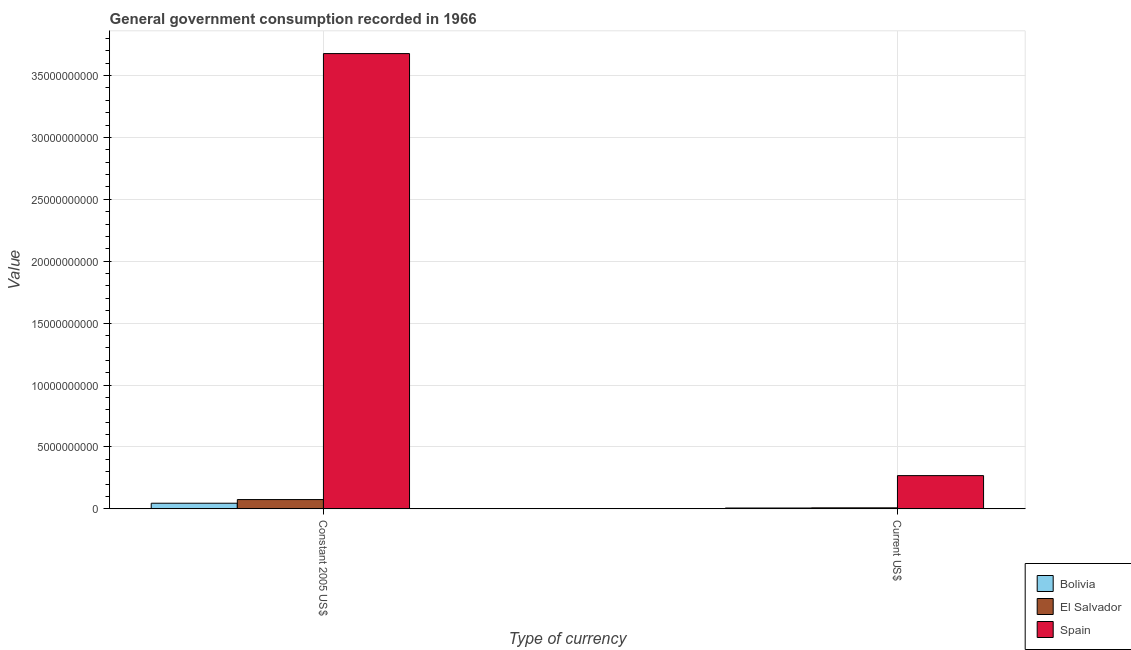Are the number of bars per tick equal to the number of legend labels?
Provide a succinct answer. Yes. Are the number of bars on each tick of the X-axis equal?
Offer a very short reply. Yes. How many bars are there on the 1st tick from the left?
Ensure brevity in your answer.  3. What is the label of the 2nd group of bars from the left?
Provide a succinct answer. Current US$. What is the value consumed in current us$ in Spain?
Your answer should be very brief. 2.68e+09. Across all countries, what is the maximum value consumed in constant 2005 us$?
Your answer should be very brief. 3.68e+1. Across all countries, what is the minimum value consumed in constant 2005 us$?
Your answer should be very brief. 4.54e+08. In which country was the value consumed in current us$ minimum?
Keep it short and to the point. Bolivia. What is the total value consumed in current us$ in the graph?
Your response must be concise. 2.83e+09. What is the difference between the value consumed in constant 2005 us$ in Spain and that in Bolivia?
Provide a succinct answer. 3.63e+1. What is the difference between the value consumed in current us$ in El Salvador and the value consumed in constant 2005 us$ in Bolivia?
Offer a terse response. -3.73e+08. What is the average value consumed in constant 2005 us$ per country?
Make the answer very short. 1.27e+1. What is the difference between the value consumed in constant 2005 us$ and value consumed in current us$ in Spain?
Your answer should be compact. 3.41e+1. In how many countries, is the value consumed in current us$ greater than 34000000000 ?
Make the answer very short. 0. What is the ratio of the value consumed in current us$ in Spain to that in Bolivia?
Ensure brevity in your answer.  39.85. Is the value consumed in current us$ in Bolivia less than that in Spain?
Provide a succinct answer. Yes. In how many countries, is the value consumed in constant 2005 us$ greater than the average value consumed in constant 2005 us$ taken over all countries?
Provide a short and direct response. 1. What is the difference between two consecutive major ticks on the Y-axis?
Offer a very short reply. 5.00e+09. Are the values on the major ticks of Y-axis written in scientific E-notation?
Make the answer very short. No. Does the graph contain any zero values?
Your answer should be very brief. No. Does the graph contain grids?
Your response must be concise. Yes. Where does the legend appear in the graph?
Your answer should be compact. Bottom right. How are the legend labels stacked?
Your answer should be compact. Vertical. What is the title of the graph?
Make the answer very short. General government consumption recorded in 1966. Does "Sweden" appear as one of the legend labels in the graph?
Provide a short and direct response. No. What is the label or title of the X-axis?
Offer a very short reply. Type of currency. What is the label or title of the Y-axis?
Ensure brevity in your answer.  Value. What is the Value of Bolivia in Constant 2005 US$?
Offer a very short reply. 4.54e+08. What is the Value in El Salvador in Constant 2005 US$?
Make the answer very short. 7.49e+08. What is the Value of Spain in Constant 2005 US$?
Give a very brief answer. 3.68e+1. What is the Value in Bolivia in Current US$?
Offer a terse response. 6.73e+07. What is the Value of El Salvador in Current US$?
Your answer should be compact. 8.10e+07. What is the Value in Spain in Current US$?
Make the answer very short. 2.68e+09. Across all Type of currency, what is the maximum Value in Bolivia?
Keep it short and to the point. 4.54e+08. Across all Type of currency, what is the maximum Value in El Salvador?
Offer a terse response. 7.49e+08. Across all Type of currency, what is the maximum Value in Spain?
Offer a terse response. 3.68e+1. Across all Type of currency, what is the minimum Value in Bolivia?
Your response must be concise. 6.73e+07. Across all Type of currency, what is the minimum Value in El Salvador?
Offer a terse response. 8.10e+07. Across all Type of currency, what is the minimum Value of Spain?
Keep it short and to the point. 2.68e+09. What is the total Value in Bolivia in the graph?
Offer a terse response. 5.22e+08. What is the total Value of El Salvador in the graph?
Make the answer very short. 8.30e+08. What is the total Value in Spain in the graph?
Your answer should be compact. 3.95e+1. What is the difference between the Value of Bolivia in Constant 2005 US$ and that in Current US$?
Make the answer very short. 3.87e+08. What is the difference between the Value in El Salvador in Constant 2005 US$ and that in Current US$?
Give a very brief answer. 6.68e+08. What is the difference between the Value of Spain in Constant 2005 US$ and that in Current US$?
Make the answer very short. 3.41e+1. What is the difference between the Value of Bolivia in Constant 2005 US$ and the Value of El Salvador in Current US$?
Your response must be concise. 3.73e+08. What is the difference between the Value of Bolivia in Constant 2005 US$ and the Value of Spain in Current US$?
Make the answer very short. -2.23e+09. What is the difference between the Value of El Salvador in Constant 2005 US$ and the Value of Spain in Current US$?
Give a very brief answer. -1.93e+09. What is the average Value in Bolivia per Type of currency?
Your answer should be compact. 2.61e+08. What is the average Value in El Salvador per Type of currency?
Your answer should be compact. 4.15e+08. What is the average Value of Spain per Type of currency?
Make the answer very short. 1.97e+1. What is the difference between the Value of Bolivia and Value of El Salvador in Constant 2005 US$?
Your answer should be very brief. -2.94e+08. What is the difference between the Value in Bolivia and Value in Spain in Constant 2005 US$?
Your answer should be very brief. -3.63e+1. What is the difference between the Value of El Salvador and Value of Spain in Constant 2005 US$?
Make the answer very short. -3.60e+1. What is the difference between the Value in Bolivia and Value in El Salvador in Current US$?
Make the answer very short. -1.37e+07. What is the difference between the Value in Bolivia and Value in Spain in Current US$?
Your answer should be very brief. -2.62e+09. What is the difference between the Value in El Salvador and Value in Spain in Current US$?
Give a very brief answer. -2.60e+09. What is the ratio of the Value in Bolivia in Constant 2005 US$ to that in Current US$?
Offer a very short reply. 6.75. What is the ratio of the Value in El Salvador in Constant 2005 US$ to that in Current US$?
Your response must be concise. 9.24. What is the ratio of the Value of Spain in Constant 2005 US$ to that in Current US$?
Keep it short and to the point. 13.7. What is the difference between the highest and the second highest Value of Bolivia?
Your response must be concise. 3.87e+08. What is the difference between the highest and the second highest Value in El Salvador?
Give a very brief answer. 6.68e+08. What is the difference between the highest and the second highest Value in Spain?
Provide a short and direct response. 3.41e+1. What is the difference between the highest and the lowest Value in Bolivia?
Offer a terse response. 3.87e+08. What is the difference between the highest and the lowest Value of El Salvador?
Give a very brief answer. 6.68e+08. What is the difference between the highest and the lowest Value of Spain?
Provide a short and direct response. 3.41e+1. 